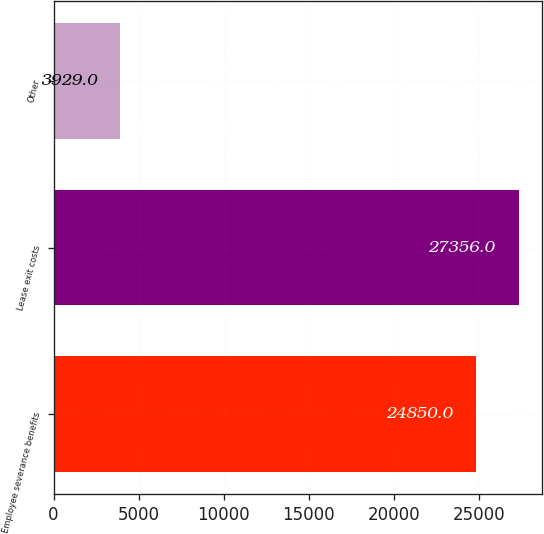<chart> <loc_0><loc_0><loc_500><loc_500><bar_chart><fcel>Employee severance benefits<fcel>Lease exit costs<fcel>Other<nl><fcel>24850<fcel>27356<fcel>3929<nl></chart> 